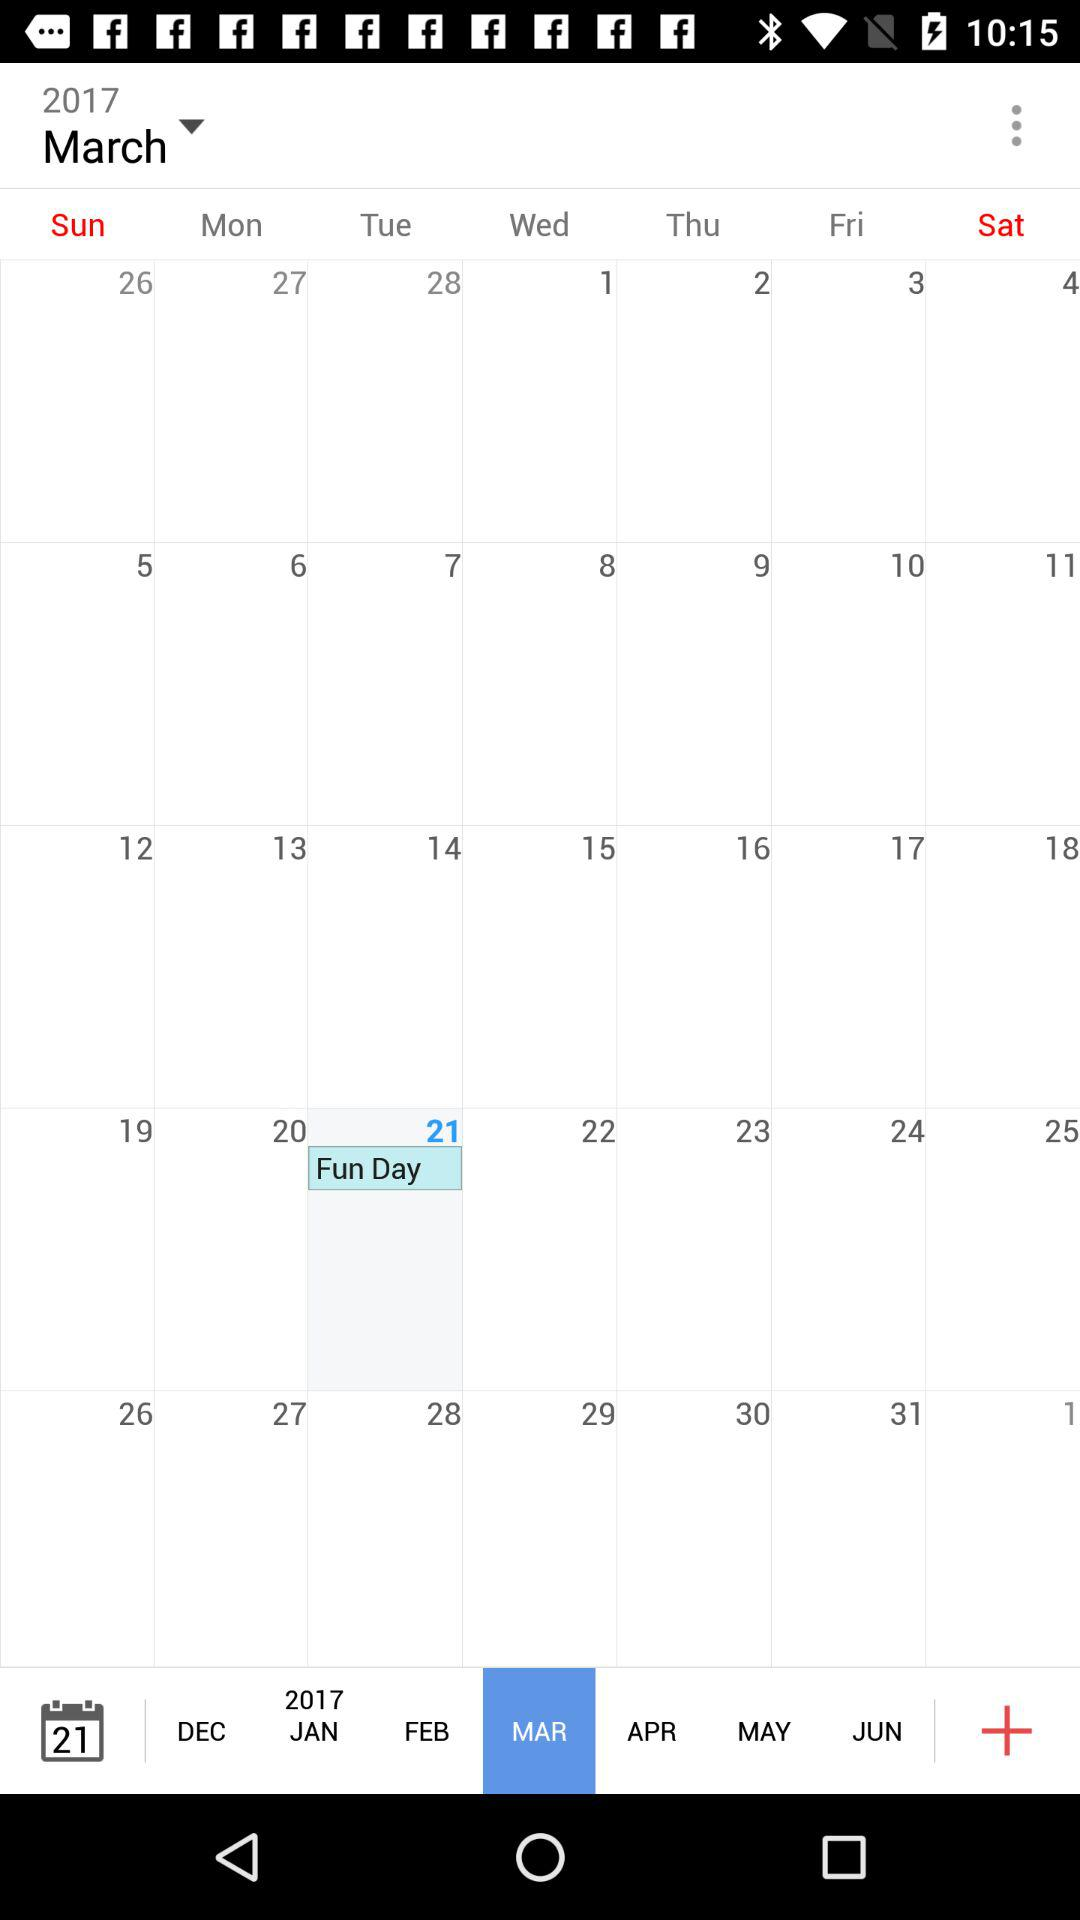What is the selected date? The selected date is Tuesday, March 21, 2017. 